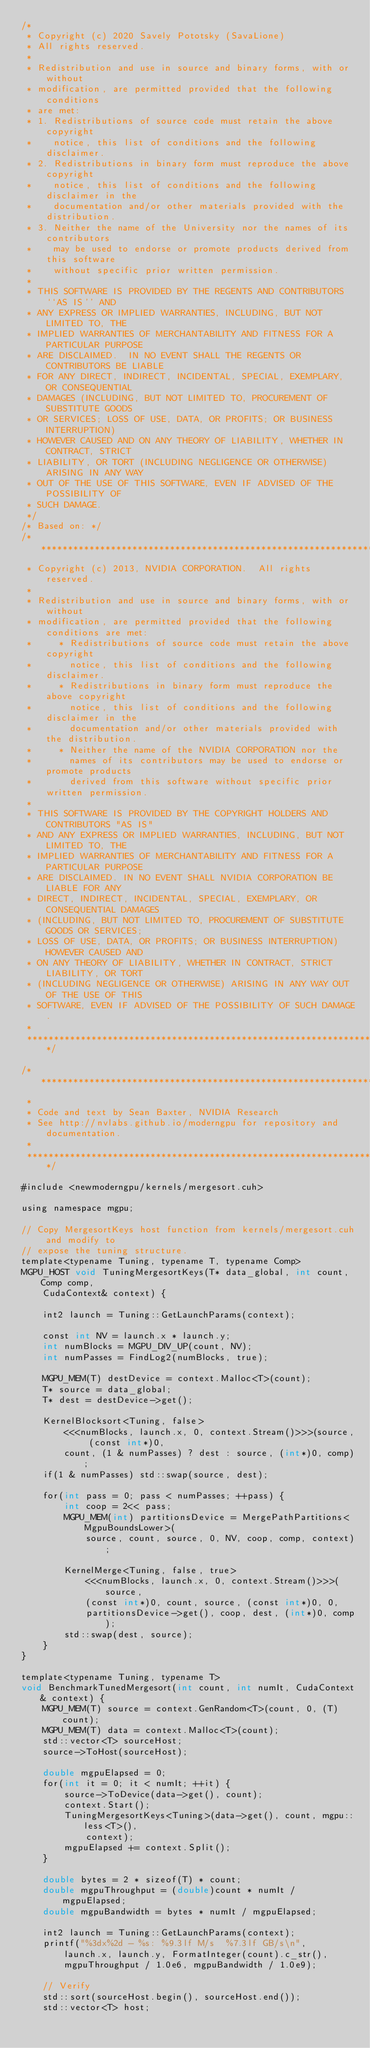<code> <loc_0><loc_0><loc_500><loc_500><_Cuda_>/*
 * Copyright (c) 2020 Savely Pototsky (SavaLione)
 * All rights reserved.
 *
 * Redistribution and use in source and binary forms, with or without
 * modification, are permitted provided that the following conditions
 * are met:
 * 1. Redistributions of source code must retain the above copyright
 *    notice, this list of conditions and the following disclaimer.
 * 2. Redistributions in binary form must reproduce the above copyright
 *    notice, this list of conditions and the following disclaimer in the
 *    documentation and/or other materials provided with the distribution.
 * 3. Neither the name of the University nor the names of its contributors
 *    may be used to endorse or promote products derived from this software
 *    without specific prior written permission.
 *
 * THIS SOFTWARE IS PROVIDED BY THE REGENTS AND CONTRIBUTORS ``AS IS'' AND
 * ANY EXPRESS OR IMPLIED WARRANTIES, INCLUDING, BUT NOT LIMITED TO, THE
 * IMPLIED WARRANTIES OF MERCHANTABILITY AND FITNESS FOR A PARTICULAR PURPOSE
 * ARE DISCLAIMED.  IN NO EVENT SHALL THE REGENTS OR CONTRIBUTORS BE LIABLE
 * FOR ANY DIRECT, INDIRECT, INCIDENTAL, SPECIAL, EXEMPLARY, OR CONSEQUENTIAL
 * DAMAGES (INCLUDING, BUT NOT LIMITED TO, PROCUREMENT OF SUBSTITUTE GOODS
 * OR SERVICES; LOSS OF USE, DATA, OR PROFITS; OR BUSINESS INTERRUPTION)
 * HOWEVER CAUSED AND ON ANY THEORY OF LIABILITY, WHETHER IN CONTRACT, STRICT
 * LIABILITY, OR TORT (INCLUDING NEGLIGENCE OR OTHERWISE) ARISING IN ANY WAY
 * OUT OF THE USE OF THIS SOFTWARE, EVEN IF ADVISED OF THE POSSIBILITY OF
 * SUCH DAMAGE.
 */
/* Based on: */
/******************************************************************************
 * Copyright (c) 2013, NVIDIA CORPORATION.  All rights reserved.
 * 
 * Redistribution and use in source and binary forms, with or without
 * modification, are permitted provided that the following conditions are met:
 *     * Redistributions of source code must retain the above copyright
 *       notice, this list of conditions and the following disclaimer.
 *     * Redistributions in binary form must reproduce the above copyright
 *       notice, this list of conditions and the following disclaimer in the
 *       documentation and/or other materials provided with the distribution.
 *     * Neither the name of the NVIDIA CORPORATION nor the
 *       names of its contributors may be used to endorse or promote products
 *       derived from this software without specific prior written permission.
 * 
 * THIS SOFTWARE IS PROVIDED BY THE COPYRIGHT HOLDERS AND CONTRIBUTORS "AS IS" 
 * AND ANY EXPRESS OR IMPLIED WARRANTIES, INCLUDING, BUT NOT LIMITED TO, THE
 * IMPLIED WARRANTIES OF MERCHANTABILITY AND FITNESS FOR A PARTICULAR PURPOSE 
 * ARE DISCLAIMED. IN NO EVENT SHALL NVIDIA CORPORATION BE LIABLE FOR ANY
 * DIRECT, INDIRECT, INCIDENTAL, SPECIAL, EXEMPLARY, OR CONSEQUENTIAL DAMAGES
 * (INCLUDING, BUT NOT LIMITED TO, PROCUREMENT OF SUBSTITUTE GOODS OR SERVICES;
 * LOSS OF USE, DATA, OR PROFITS; OR BUSINESS INTERRUPTION) HOWEVER CAUSED AND
 * ON ANY THEORY OF LIABILITY, WHETHER IN CONTRACT, STRICT LIABILITY, OR TORT
 * (INCLUDING NEGLIGENCE OR OTHERWISE) ARISING IN ANY WAY OUT OF THE USE OF THIS
 * SOFTWARE, EVEN IF ADVISED OF THE POSSIBILITY OF SUCH DAMAGE.
 *
 ******************************************************************************/

/******************************************************************************
 *
 * Code and text by Sean Baxter, NVIDIA Research
 * See http://nvlabs.github.io/moderngpu for repository and documentation.
 *
 ******************************************************************************/

#include <newmoderngpu/kernels/mergesort.cuh>

using namespace mgpu;

// Copy MergesortKeys host function from kernels/mergesort.cuh and modify to
// expose the tuning structure.
template<typename Tuning, typename T, typename Comp>
MGPU_HOST void TuningMergesortKeys(T* data_global, int count, Comp comp,
	CudaContext& context) {
	
	int2 launch = Tuning::GetLaunchParams(context);
	
	const int NV = launch.x * launch.y;
	int numBlocks = MGPU_DIV_UP(count, NV);
	int numPasses = FindLog2(numBlocks, true);

	MGPU_MEM(T) destDevice = context.Malloc<T>(count);
	T* source = data_global;
	T* dest = destDevice->get();

	KernelBlocksort<Tuning, false>
		<<<numBlocks, launch.x, 0, context.Stream()>>>(source, (const int*)0,
		count, (1 & numPasses) ? dest : source, (int*)0, comp);
	if(1 & numPasses) std::swap(source, dest);

	for(int pass = 0; pass < numPasses; ++pass) {
		int coop = 2<< pass;
		MGPU_MEM(int) partitionsDevice = MergePathPartitions<MgpuBoundsLower>(
			source, count, source, 0, NV, coop, comp, context);
		
		KernelMerge<Tuning, false, true>
			<<<numBlocks, launch.x, 0, context.Stream()>>>(source, 
			(const int*)0, count, source, (const int*)0, 0, 
			partitionsDevice->get(), coop, dest, (int*)0, comp);
		std::swap(dest, source);
	}
}

template<typename Tuning, typename T>
void BenchmarkTunedMergesort(int count, int numIt, CudaContext& context) {
	MGPU_MEM(T) source = context.GenRandom<T>(count, 0, (T)count);
	MGPU_MEM(T) data = context.Malloc<T>(count);
	std::vector<T> sourceHost;
	source->ToHost(sourceHost);

	double mgpuElapsed = 0;
	for(int it = 0; it < numIt; ++it) {
		source->ToDevice(data->get(), count);
		context.Start();
		TuningMergesortKeys<Tuning>(data->get(), count, mgpu::less<T>(),
			context);
		mgpuElapsed += context.Split();
	}
	
	double bytes = 2 * sizeof(T) * count;
	double mgpuThroughput = (double)count * numIt / mgpuElapsed;
	double mgpuBandwidth = bytes * numIt / mgpuElapsed;

	int2 launch = Tuning::GetLaunchParams(context);
	printf("%3dx%2d - %s: %9.3lf M/s  %7.3lf GB/s\n",
		launch.x, launch.y, FormatInteger(count).c_str(),
		mgpuThroughput / 1.0e6, mgpuBandwidth / 1.0e9);
	
	// Verify
	std::sort(sourceHost.begin(), sourceHost.end());
	std::vector<T> host;</code> 